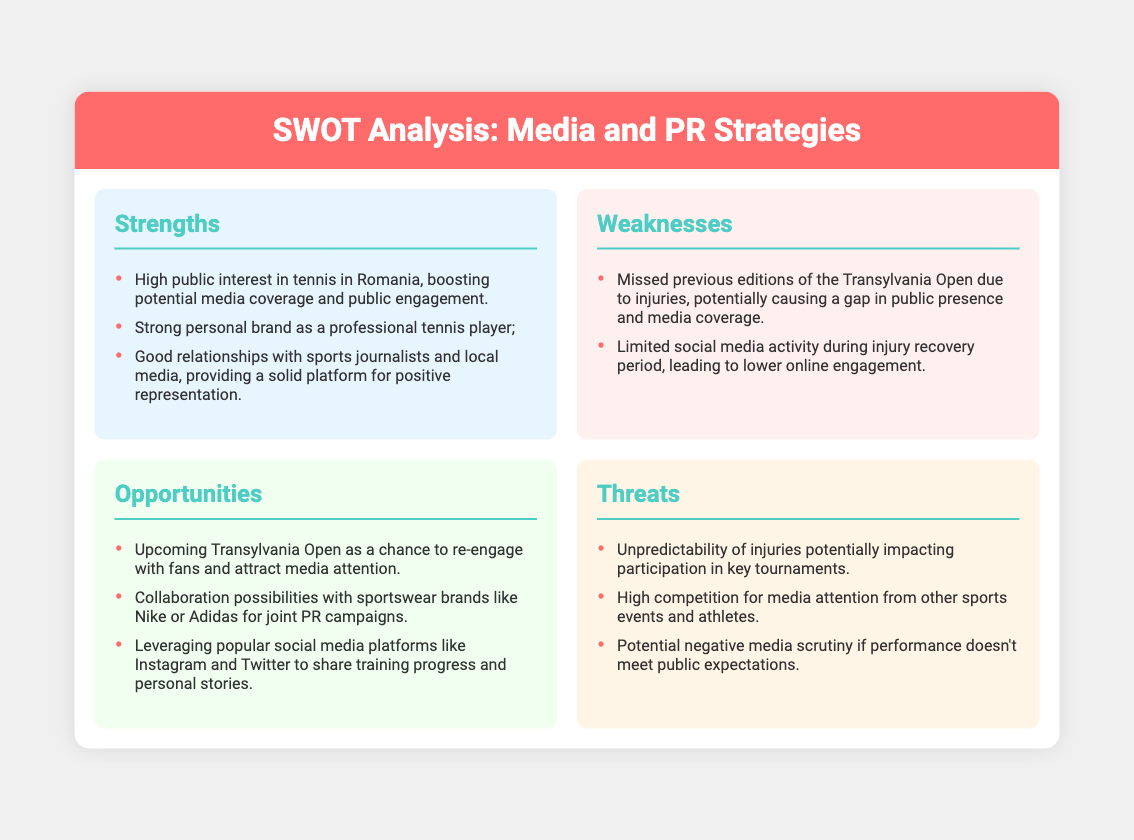What is the upcoming event mentioned? The document indicates that the upcoming event is the Transylvania Open, which is highlighted as a chance to re-engage with fans.
Answer: Transylvania Open What is one strength listed in the analysis? The analysis mentions that there is high public interest in tennis in Romania, which boosts potential media coverage.
Answer: High public interest in tennis in Romania What is a weakness related to past competitions? The document states that the player missed previous editions of the Transylvania Open due to injuries, potentially affecting public presence.
Answer: Missed previous editions of the Transylvania Open What is one opportunity for collaboration mentioned? The analysis suggests collaboration possibilities with sportswear brands for joint PR campaigns.
Answer: Collaboration with sportswear brands What is a potential threat regarding injuries? The document indicates that the unpredictability of injuries is a threat that could impact participation in key tournaments.
Answer: Unpredictability of injuries How many strengths are listed in the SWOT analysis? The analysis lists three strengths associated with media and PR strategies.
Answer: Three strengths What type of media does the player have good relationships with? The document specifies that the player has good relationships with sports journalists and local media.
Answer: Sports journalists and local media Which social media platforms are mentioned as opportunities? The analysis highlights popular platforms like Instagram and Twitter for sharing training progress and personal stories.
Answer: Instagram and Twitter What is one potential risk regarding public expectations? The document states there could be potential negative media scrutiny if performance doesn't meet public expectations.
Answer: Negative media scrutiny 